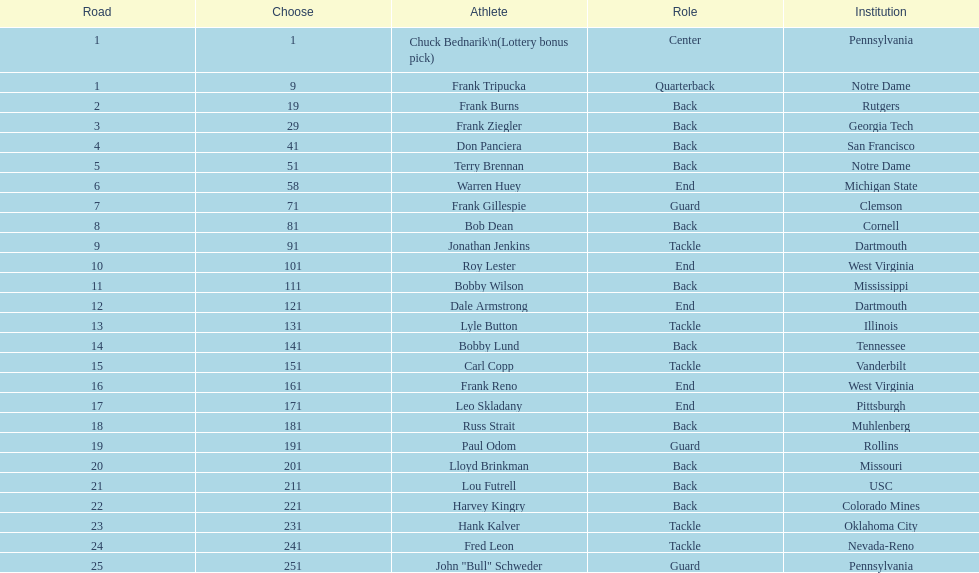Most prevalent school Pennsylvania. 